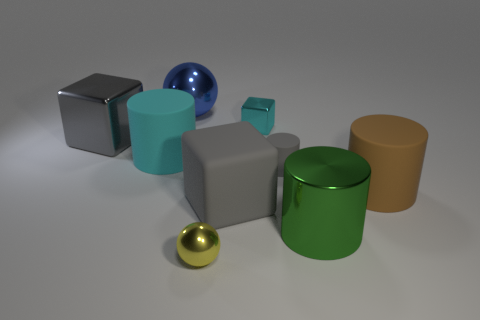Subtract all cyan balls. How many gray cubes are left? 2 Add 1 green things. How many objects exist? 10 Subtract all big brown matte cylinders. How many cylinders are left? 3 Subtract 1 cubes. How many cubes are left? 2 Subtract all gray cylinders. How many cylinders are left? 3 Subtract all cubes. How many objects are left? 6 Subtract all purple cylinders. Subtract all red spheres. How many cylinders are left? 4 Subtract 0 purple cubes. How many objects are left? 9 Subtract all small yellow things. Subtract all gray cylinders. How many objects are left? 7 Add 2 big cyan rubber things. How many big cyan rubber things are left? 3 